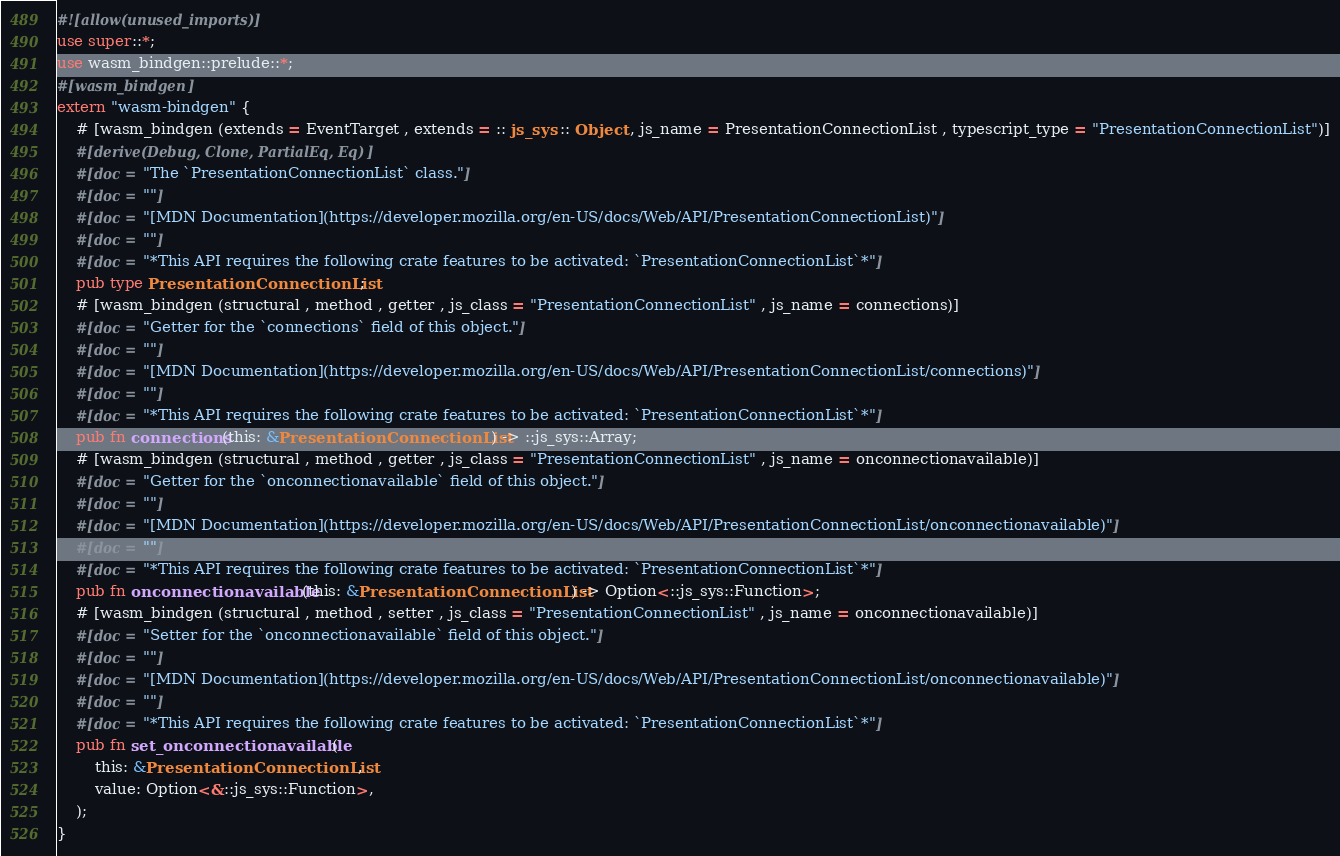<code> <loc_0><loc_0><loc_500><loc_500><_Rust_>#![allow(unused_imports)]
use super::*;
use wasm_bindgen::prelude::*;
#[wasm_bindgen]
extern "wasm-bindgen" {
    # [wasm_bindgen (extends = EventTarget , extends = :: js_sys :: Object , js_name = PresentationConnectionList , typescript_type = "PresentationConnectionList")]
    #[derive(Debug, Clone, PartialEq, Eq)]
    #[doc = "The `PresentationConnectionList` class."]
    #[doc = ""]
    #[doc = "[MDN Documentation](https://developer.mozilla.org/en-US/docs/Web/API/PresentationConnectionList)"]
    #[doc = ""]
    #[doc = "*This API requires the following crate features to be activated: `PresentationConnectionList`*"]
    pub type PresentationConnectionList;
    # [wasm_bindgen (structural , method , getter , js_class = "PresentationConnectionList" , js_name = connections)]
    #[doc = "Getter for the `connections` field of this object."]
    #[doc = ""]
    #[doc = "[MDN Documentation](https://developer.mozilla.org/en-US/docs/Web/API/PresentationConnectionList/connections)"]
    #[doc = ""]
    #[doc = "*This API requires the following crate features to be activated: `PresentationConnectionList`*"]
    pub fn connections(this: &PresentationConnectionList) -> ::js_sys::Array;
    # [wasm_bindgen (structural , method , getter , js_class = "PresentationConnectionList" , js_name = onconnectionavailable)]
    #[doc = "Getter for the `onconnectionavailable` field of this object."]
    #[doc = ""]
    #[doc = "[MDN Documentation](https://developer.mozilla.org/en-US/docs/Web/API/PresentationConnectionList/onconnectionavailable)"]
    #[doc = ""]
    #[doc = "*This API requires the following crate features to be activated: `PresentationConnectionList`*"]
    pub fn onconnectionavailable(this: &PresentationConnectionList) -> Option<::js_sys::Function>;
    # [wasm_bindgen (structural , method , setter , js_class = "PresentationConnectionList" , js_name = onconnectionavailable)]
    #[doc = "Setter for the `onconnectionavailable` field of this object."]
    #[doc = ""]
    #[doc = "[MDN Documentation](https://developer.mozilla.org/en-US/docs/Web/API/PresentationConnectionList/onconnectionavailable)"]
    #[doc = ""]
    #[doc = "*This API requires the following crate features to be activated: `PresentationConnectionList`*"]
    pub fn set_onconnectionavailable(
        this: &PresentationConnectionList,
        value: Option<&::js_sys::Function>,
    );
}
</code> 